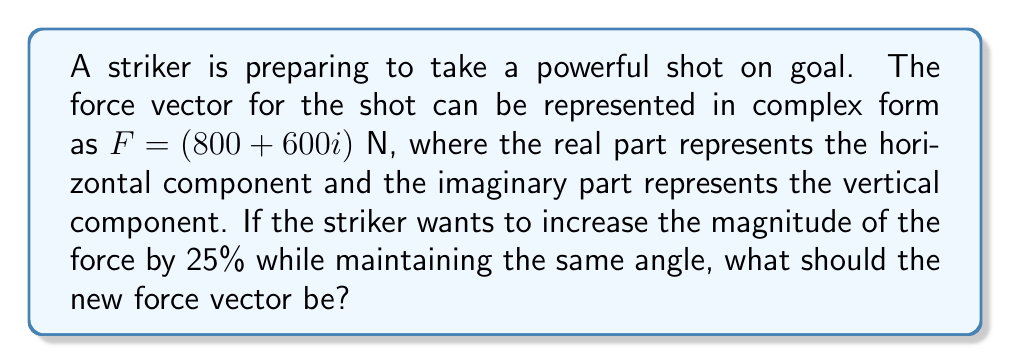Give your solution to this math problem. Let's approach this step-by-step:

1) First, we need to find the current magnitude of the force vector:
   $|F| = \sqrt{800^2 + 600^2} = \sqrt{640000 + 360000} = \sqrt{1000000} = 1000$ N

2) The angle of the force vector can be calculated using:
   $\theta = \tan^{-1}(\frac{Im(F)}{Re(F)}) = \tan^{-1}(\frac{600}{800}) \approx 36.87°$

3) To increase the magnitude by 25%, we multiply the current magnitude by 1.25:
   New magnitude = $1000 * 1.25 = 1250$ N

4) To maintain the same angle while increasing the magnitude, we can use the polar form of complex numbers:
   $F_{new} = 1250(\cos 36.87° + i \sin 36.87°)$

5) Converting back to rectangular form:
   $F_{new} = 1250 \cos 36.87° + 1250i \sin 36.87°$

6) Calculating the real and imaginary parts:
   $Re(F_{new}) = 1250 \cos 36.87° \approx 1000$
   $Im(F_{new}) = 1250 \sin 36.87° \approx 750$

Therefore, the new force vector is approximately $(1000 + 750i)$ N.
Answer: $(1000 + 750i)$ N 